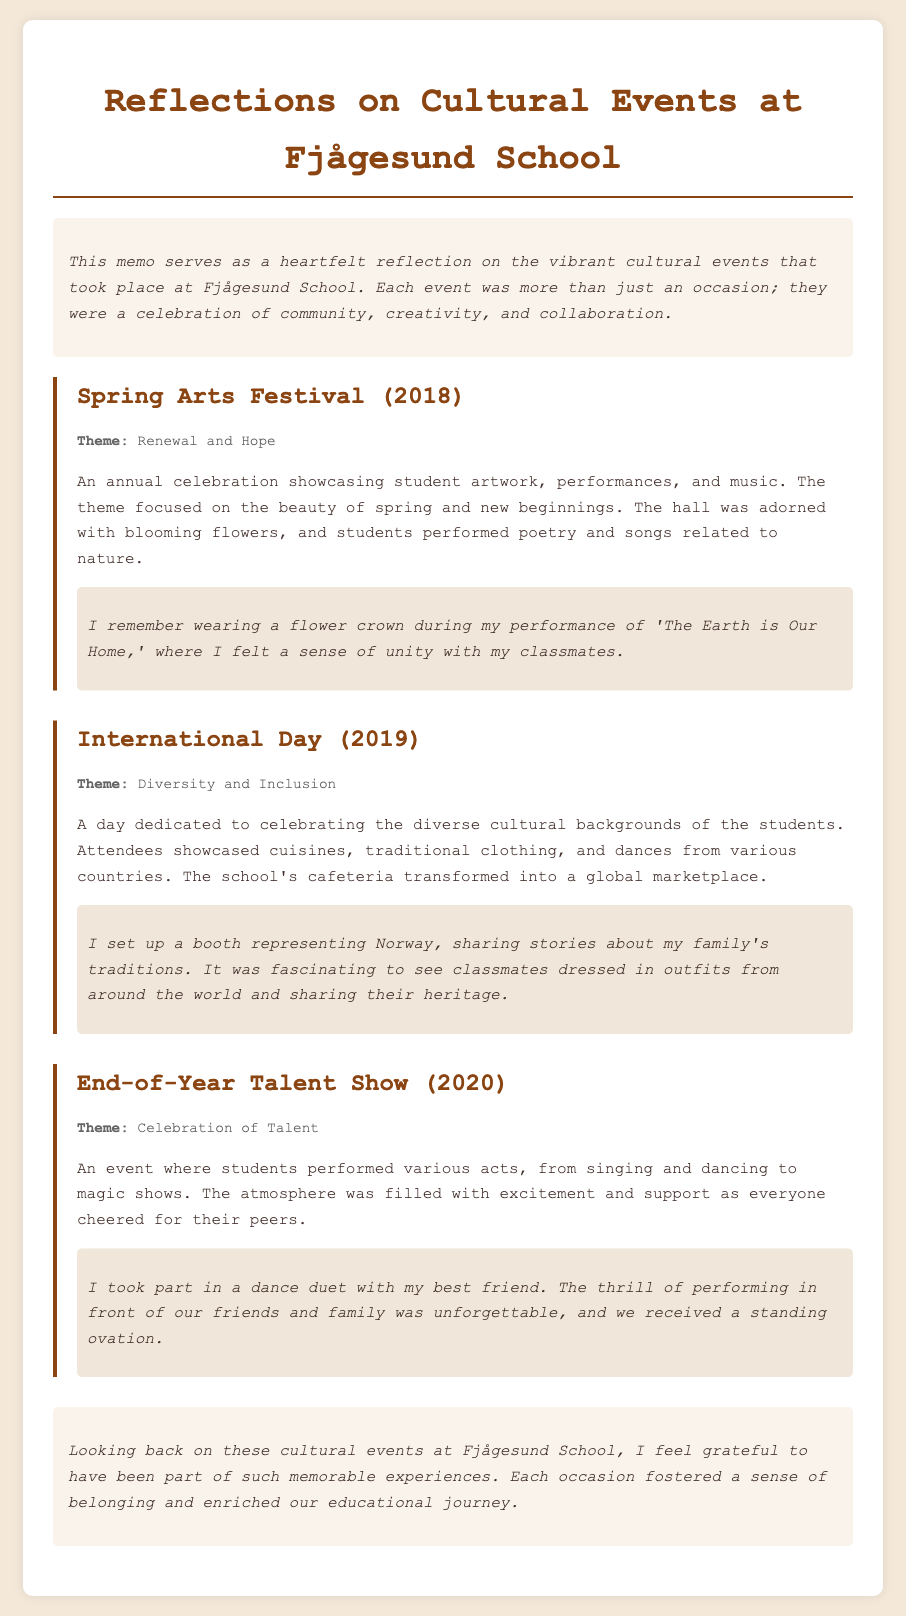What was the theme of the Spring Arts Festival in 2018? The theme for the Spring Arts Festival was about the beauty of spring and new beginnings, encapsulated in the phrase "Renewal and Hope."
Answer: Renewal and Hope What year was the International Day held? The document mentions the International Day took place in 2019.
Answer: 2019 What activity did the students perform at the End-of-Year Talent Show? The students showcased various acts, including dancing, singing, and magic shows, highlighting the celebration of talent.
Answer: Talent Show What personal item did the author wear during the Spring Arts Festival? The author specifically mentions wearing a flower crown during their performance.
Answer: Flower crown How did the school's cafeteria transform during the International Day? The cafeteria changed into a global marketplace where various cuisines and cultures were displayed.
Answer: Marketplace What strong emotion did the author express about their experiences at the cultural events? The author felt grateful to have been part of such memorable cultural experiences at the school, signifying appreciation and nostalgia.
Answer: Grateful What type of performances were included in the End-of-Year Talent Show? The performances at the talent show included acts like dancing, singing, and magic tricks, showcasing a range of talents.
Answer: Various acts What was the central theme of the International Day? The main theme highlighting the diverse backgrounds of students was centered around "Diversity and Inclusion."
Answer: Diversity and Inclusion What reflection does the author provide about their time at Fjågesund School? The author reflects on their experiences and expresses a sense of belonging and enrichment from the events held at the school.
Answer: Sense of belonging 